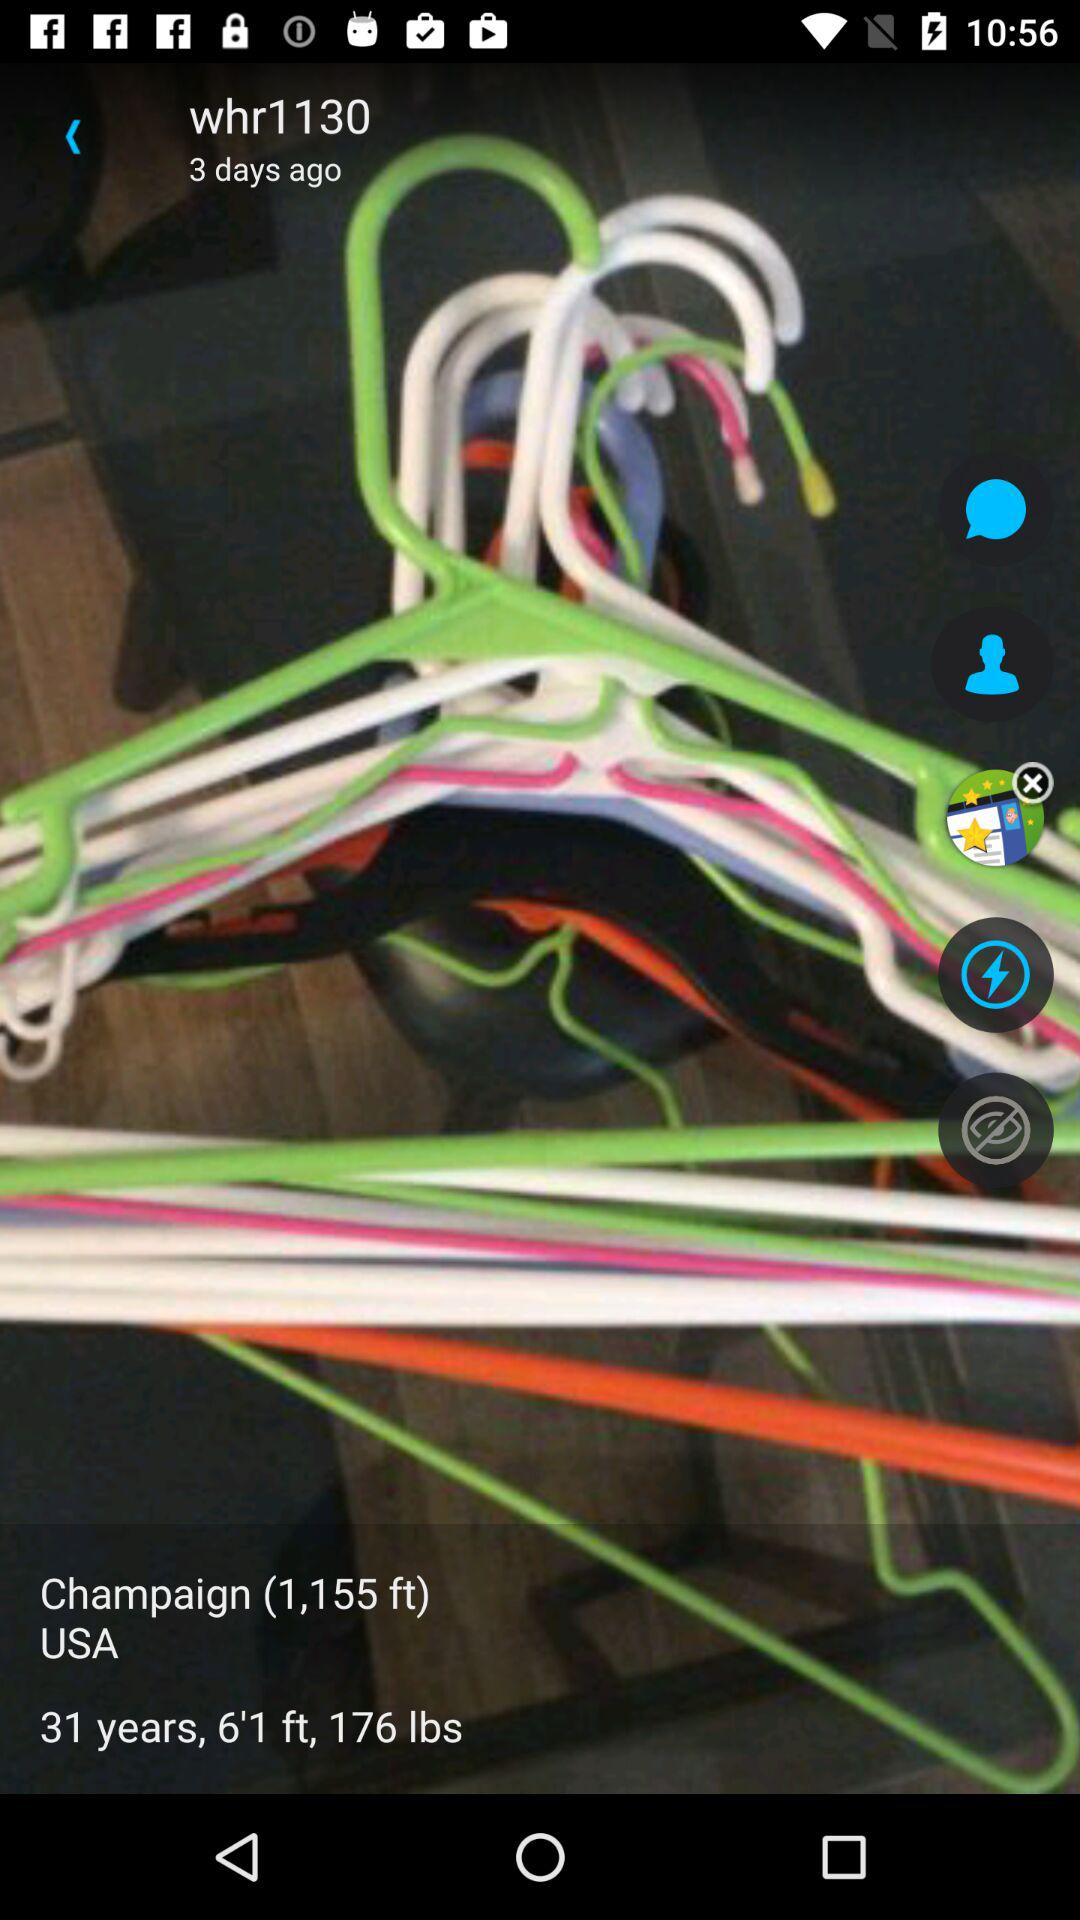What is the country's name? The country's name is the USA. 